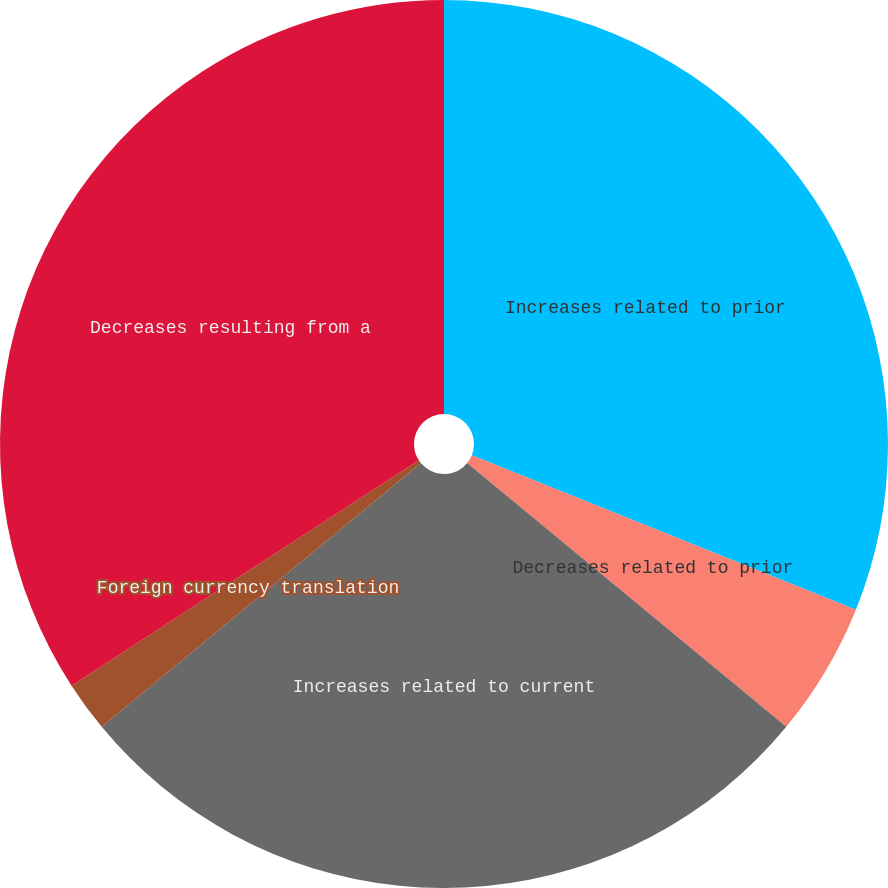<chart> <loc_0><loc_0><loc_500><loc_500><pie_chart><fcel>Increases related to prior<fcel>Decreases related to prior<fcel>Increases related to current<fcel>Foreign currency translation<fcel>Decreases resulting from a<nl><fcel>31.09%<fcel>4.9%<fcel>28.02%<fcel>1.83%<fcel>34.16%<nl></chart> 